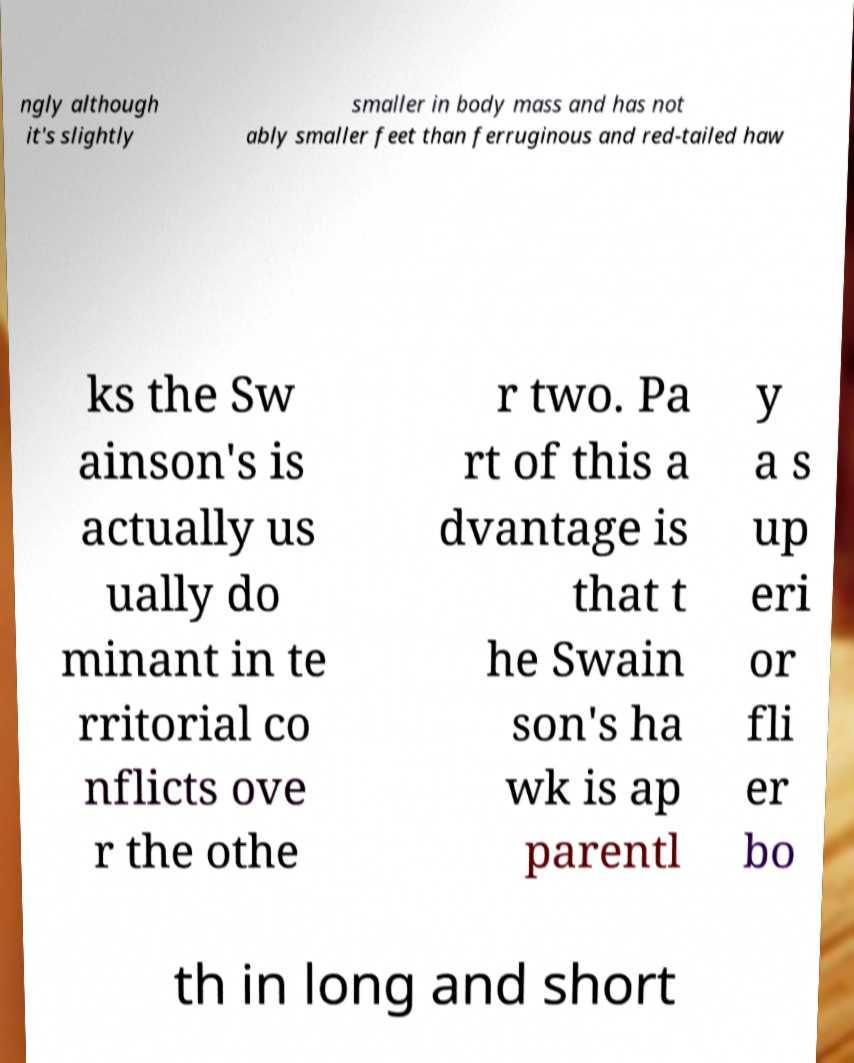Please identify and transcribe the text found in this image. ngly although it's slightly smaller in body mass and has not ably smaller feet than ferruginous and red-tailed haw ks the Sw ainson's is actually us ually do minant in te rritorial co nflicts ove r the othe r two. Pa rt of this a dvantage is that t he Swain son's ha wk is ap parentl y a s up eri or fli er bo th in long and short 